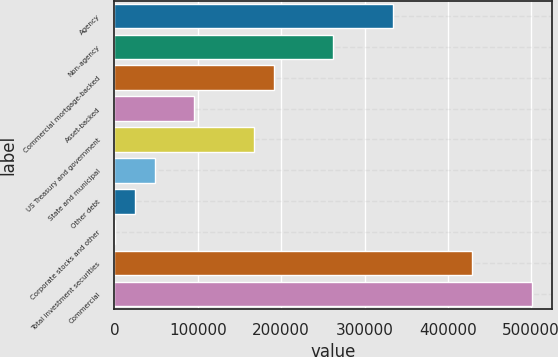Convert chart. <chart><loc_0><loc_0><loc_500><loc_500><bar_chart><fcel>Agency<fcel>Non-agency<fcel>Commercial mortgage-backed<fcel>Asset-backed<fcel>US Treasury and government<fcel>State and municipal<fcel>Other debt<fcel>Corporate stocks and other<fcel>Total investment securities<fcel>Commercial<nl><fcel>333723<fcel>262296<fcel>190869<fcel>95633.6<fcel>167060<fcel>48015.8<fcel>24206.9<fcel>398<fcel>428958<fcel>500385<nl></chart> 